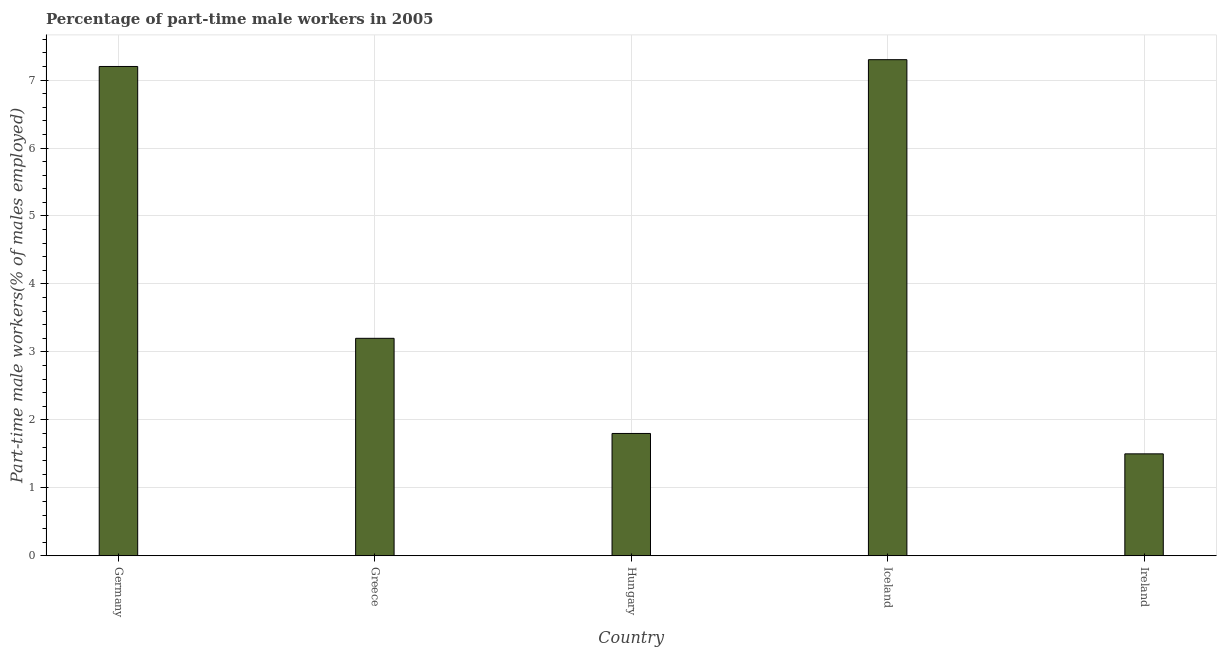What is the title of the graph?
Keep it short and to the point. Percentage of part-time male workers in 2005. What is the label or title of the X-axis?
Ensure brevity in your answer.  Country. What is the label or title of the Y-axis?
Provide a succinct answer. Part-time male workers(% of males employed). What is the percentage of part-time male workers in Ireland?
Ensure brevity in your answer.  1.5. Across all countries, what is the maximum percentage of part-time male workers?
Your response must be concise. 7.3. In which country was the percentage of part-time male workers minimum?
Offer a very short reply. Ireland. What is the sum of the percentage of part-time male workers?
Your answer should be very brief. 21. What is the difference between the percentage of part-time male workers in Germany and Hungary?
Provide a succinct answer. 5.4. What is the average percentage of part-time male workers per country?
Make the answer very short. 4.2. What is the median percentage of part-time male workers?
Ensure brevity in your answer.  3.2. What is the ratio of the percentage of part-time male workers in Iceland to that in Ireland?
Your response must be concise. 4.87. Is the percentage of part-time male workers in Iceland less than that in Ireland?
Provide a short and direct response. No. Is the difference between the percentage of part-time male workers in Hungary and Iceland greater than the difference between any two countries?
Offer a terse response. No. What is the difference between the highest and the lowest percentage of part-time male workers?
Offer a very short reply. 5.8. How many bars are there?
Your answer should be very brief. 5. Are all the bars in the graph horizontal?
Make the answer very short. No. How many countries are there in the graph?
Ensure brevity in your answer.  5. What is the difference between two consecutive major ticks on the Y-axis?
Provide a short and direct response. 1. What is the Part-time male workers(% of males employed) in Germany?
Offer a terse response. 7.2. What is the Part-time male workers(% of males employed) in Greece?
Your answer should be compact. 3.2. What is the Part-time male workers(% of males employed) in Hungary?
Your answer should be compact. 1.8. What is the Part-time male workers(% of males employed) in Iceland?
Offer a very short reply. 7.3. What is the Part-time male workers(% of males employed) in Ireland?
Make the answer very short. 1.5. What is the difference between the Part-time male workers(% of males employed) in Germany and Greece?
Give a very brief answer. 4. What is the difference between the Part-time male workers(% of males employed) in Germany and Hungary?
Your answer should be very brief. 5.4. What is the difference between the Part-time male workers(% of males employed) in Hungary and Iceland?
Your response must be concise. -5.5. What is the ratio of the Part-time male workers(% of males employed) in Germany to that in Greece?
Provide a short and direct response. 2.25. What is the ratio of the Part-time male workers(% of males employed) in Germany to that in Iceland?
Offer a terse response. 0.99. What is the ratio of the Part-time male workers(% of males employed) in Germany to that in Ireland?
Ensure brevity in your answer.  4.8. What is the ratio of the Part-time male workers(% of males employed) in Greece to that in Hungary?
Provide a succinct answer. 1.78. What is the ratio of the Part-time male workers(% of males employed) in Greece to that in Iceland?
Ensure brevity in your answer.  0.44. What is the ratio of the Part-time male workers(% of males employed) in Greece to that in Ireland?
Your response must be concise. 2.13. What is the ratio of the Part-time male workers(% of males employed) in Hungary to that in Iceland?
Keep it short and to the point. 0.25. What is the ratio of the Part-time male workers(% of males employed) in Iceland to that in Ireland?
Offer a terse response. 4.87. 